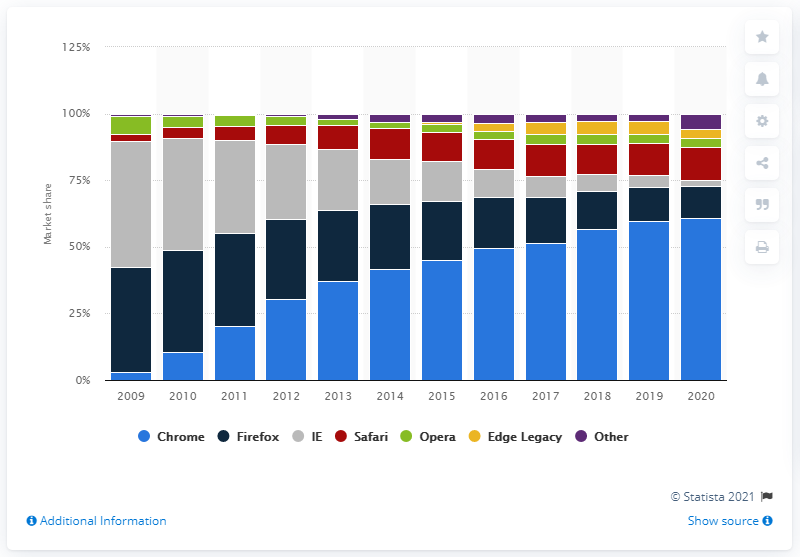Specify some key components in this picture. According to reliable sources, Google Chrome is the most widely used browser in Europe. 